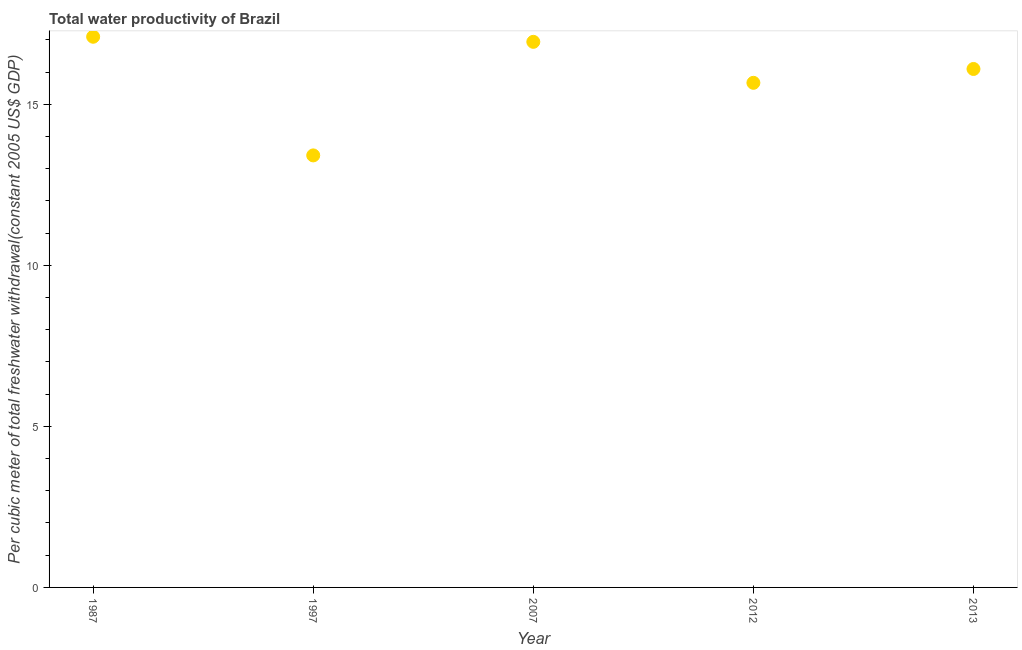What is the total water productivity in 1987?
Keep it short and to the point. 17.09. Across all years, what is the maximum total water productivity?
Give a very brief answer. 17.09. Across all years, what is the minimum total water productivity?
Offer a very short reply. 13.41. In which year was the total water productivity maximum?
Your answer should be very brief. 1987. What is the sum of the total water productivity?
Your answer should be compact. 79.2. What is the difference between the total water productivity in 1997 and 2013?
Keep it short and to the point. -2.68. What is the average total water productivity per year?
Keep it short and to the point. 15.84. What is the median total water productivity?
Your answer should be very brief. 16.09. Do a majority of the years between 1987 and 2007 (inclusive) have total water productivity greater than 1 US$?
Your answer should be compact. Yes. What is the ratio of the total water productivity in 1987 to that in 2013?
Make the answer very short. 1.06. Is the difference between the total water productivity in 1987 and 2007 greater than the difference between any two years?
Your answer should be very brief. No. What is the difference between the highest and the second highest total water productivity?
Give a very brief answer. 0.16. Is the sum of the total water productivity in 1987 and 2012 greater than the maximum total water productivity across all years?
Your answer should be very brief. Yes. What is the difference between the highest and the lowest total water productivity?
Offer a very short reply. 3.68. In how many years, is the total water productivity greater than the average total water productivity taken over all years?
Your answer should be compact. 3. How many dotlines are there?
Your answer should be very brief. 1. How many years are there in the graph?
Your answer should be compact. 5. What is the difference between two consecutive major ticks on the Y-axis?
Your answer should be compact. 5. Are the values on the major ticks of Y-axis written in scientific E-notation?
Provide a succinct answer. No. Does the graph contain any zero values?
Make the answer very short. No. What is the title of the graph?
Keep it short and to the point. Total water productivity of Brazil. What is the label or title of the Y-axis?
Keep it short and to the point. Per cubic meter of total freshwater withdrawal(constant 2005 US$ GDP). What is the Per cubic meter of total freshwater withdrawal(constant 2005 US$ GDP) in 1987?
Give a very brief answer. 17.09. What is the Per cubic meter of total freshwater withdrawal(constant 2005 US$ GDP) in 1997?
Ensure brevity in your answer.  13.41. What is the Per cubic meter of total freshwater withdrawal(constant 2005 US$ GDP) in 2007?
Provide a succinct answer. 16.94. What is the Per cubic meter of total freshwater withdrawal(constant 2005 US$ GDP) in 2012?
Ensure brevity in your answer.  15.66. What is the Per cubic meter of total freshwater withdrawal(constant 2005 US$ GDP) in 2013?
Offer a terse response. 16.09. What is the difference between the Per cubic meter of total freshwater withdrawal(constant 2005 US$ GDP) in 1987 and 1997?
Your response must be concise. 3.68. What is the difference between the Per cubic meter of total freshwater withdrawal(constant 2005 US$ GDP) in 1987 and 2007?
Your answer should be compact. 0.16. What is the difference between the Per cubic meter of total freshwater withdrawal(constant 2005 US$ GDP) in 1987 and 2012?
Provide a short and direct response. 1.43. What is the difference between the Per cubic meter of total freshwater withdrawal(constant 2005 US$ GDP) in 1987 and 2013?
Give a very brief answer. 1. What is the difference between the Per cubic meter of total freshwater withdrawal(constant 2005 US$ GDP) in 1997 and 2007?
Your answer should be very brief. -3.53. What is the difference between the Per cubic meter of total freshwater withdrawal(constant 2005 US$ GDP) in 1997 and 2012?
Your answer should be compact. -2.25. What is the difference between the Per cubic meter of total freshwater withdrawal(constant 2005 US$ GDP) in 1997 and 2013?
Provide a short and direct response. -2.68. What is the difference between the Per cubic meter of total freshwater withdrawal(constant 2005 US$ GDP) in 2007 and 2012?
Your answer should be very brief. 1.27. What is the difference between the Per cubic meter of total freshwater withdrawal(constant 2005 US$ GDP) in 2007 and 2013?
Provide a short and direct response. 0.84. What is the difference between the Per cubic meter of total freshwater withdrawal(constant 2005 US$ GDP) in 2012 and 2013?
Give a very brief answer. -0.43. What is the ratio of the Per cubic meter of total freshwater withdrawal(constant 2005 US$ GDP) in 1987 to that in 1997?
Your response must be concise. 1.27. What is the ratio of the Per cubic meter of total freshwater withdrawal(constant 2005 US$ GDP) in 1987 to that in 2012?
Give a very brief answer. 1.09. What is the ratio of the Per cubic meter of total freshwater withdrawal(constant 2005 US$ GDP) in 1987 to that in 2013?
Ensure brevity in your answer.  1.06. What is the ratio of the Per cubic meter of total freshwater withdrawal(constant 2005 US$ GDP) in 1997 to that in 2007?
Provide a succinct answer. 0.79. What is the ratio of the Per cubic meter of total freshwater withdrawal(constant 2005 US$ GDP) in 1997 to that in 2012?
Your answer should be compact. 0.86. What is the ratio of the Per cubic meter of total freshwater withdrawal(constant 2005 US$ GDP) in 1997 to that in 2013?
Your response must be concise. 0.83. What is the ratio of the Per cubic meter of total freshwater withdrawal(constant 2005 US$ GDP) in 2007 to that in 2012?
Your answer should be very brief. 1.08. What is the ratio of the Per cubic meter of total freshwater withdrawal(constant 2005 US$ GDP) in 2007 to that in 2013?
Offer a terse response. 1.05. What is the ratio of the Per cubic meter of total freshwater withdrawal(constant 2005 US$ GDP) in 2012 to that in 2013?
Your answer should be very brief. 0.97. 